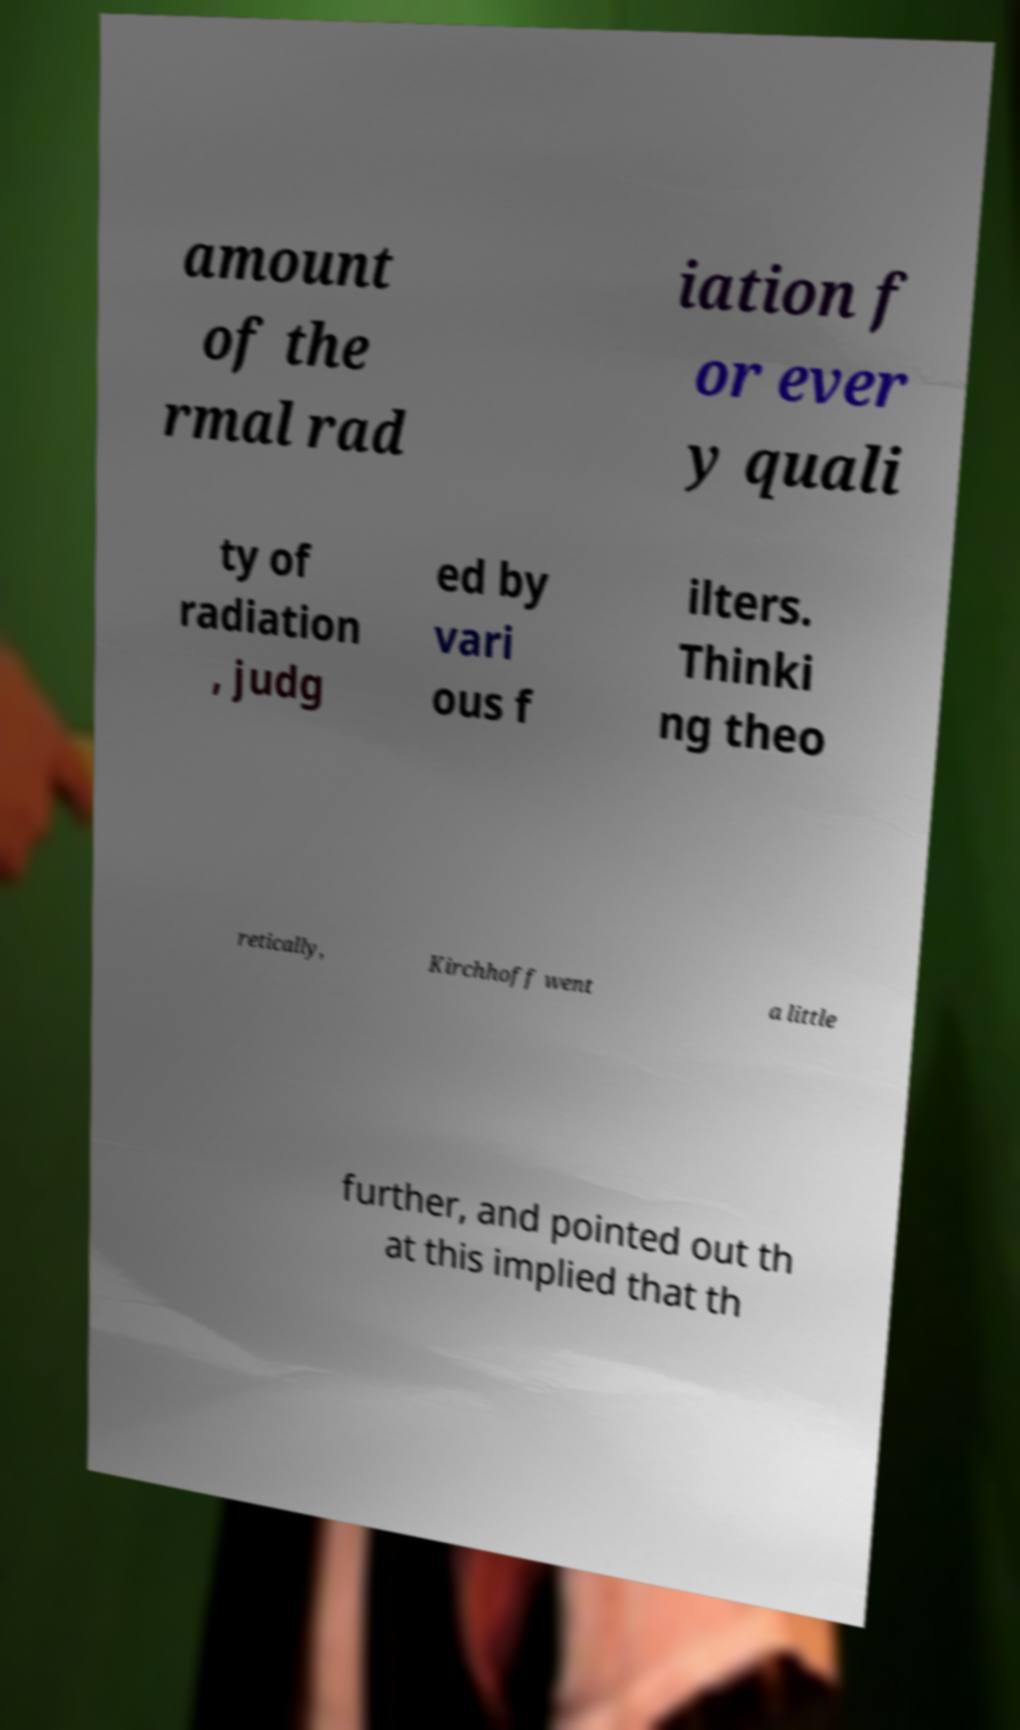Could you assist in decoding the text presented in this image and type it out clearly? amount of the rmal rad iation f or ever y quali ty of radiation , judg ed by vari ous f ilters. Thinki ng theo retically, Kirchhoff went a little further, and pointed out th at this implied that th 